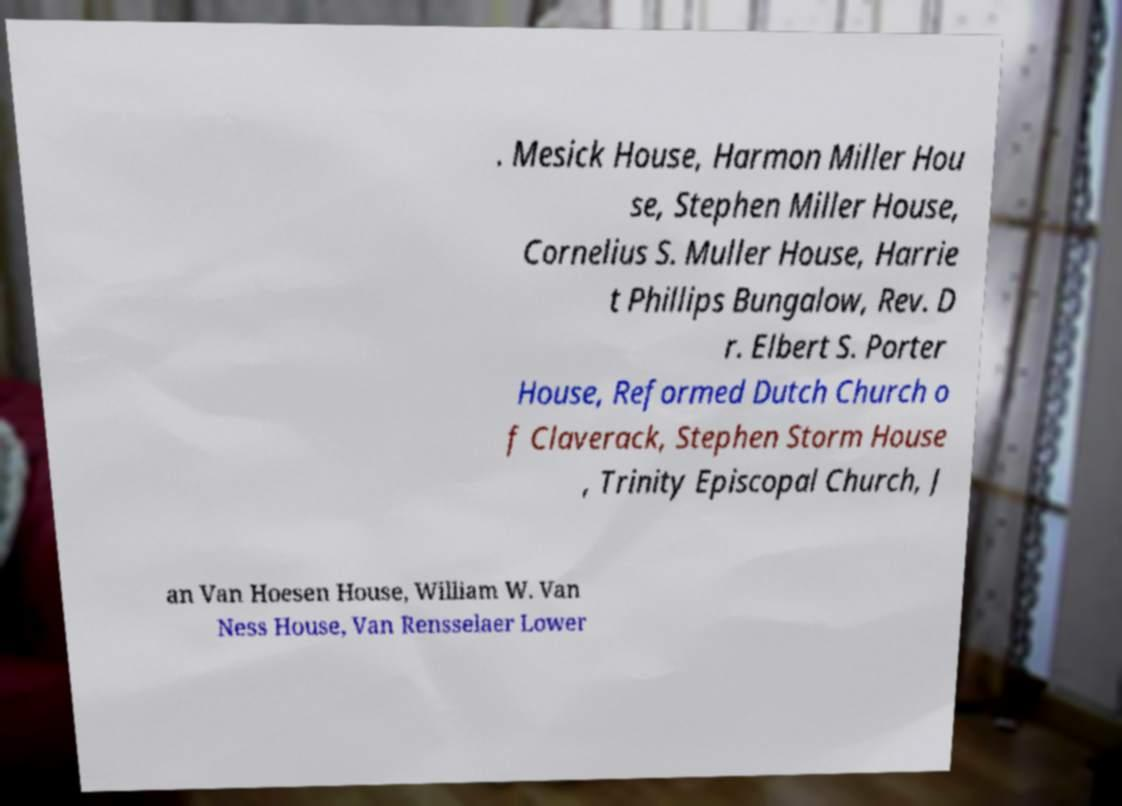Please identify and transcribe the text found in this image. . Mesick House, Harmon Miller Hou se, Stephen Miller House, Cornelius S. Muller House, Harrie t Phillips Bungalow, Rev. D r. Elbert S. Porter House, Reformed Dutch Church o f Claverack, Stephen Storm House , Trinity Episcopal Church, J an Van Hoesen House, William W. Van Ness House, Van Rensselaer Lower 